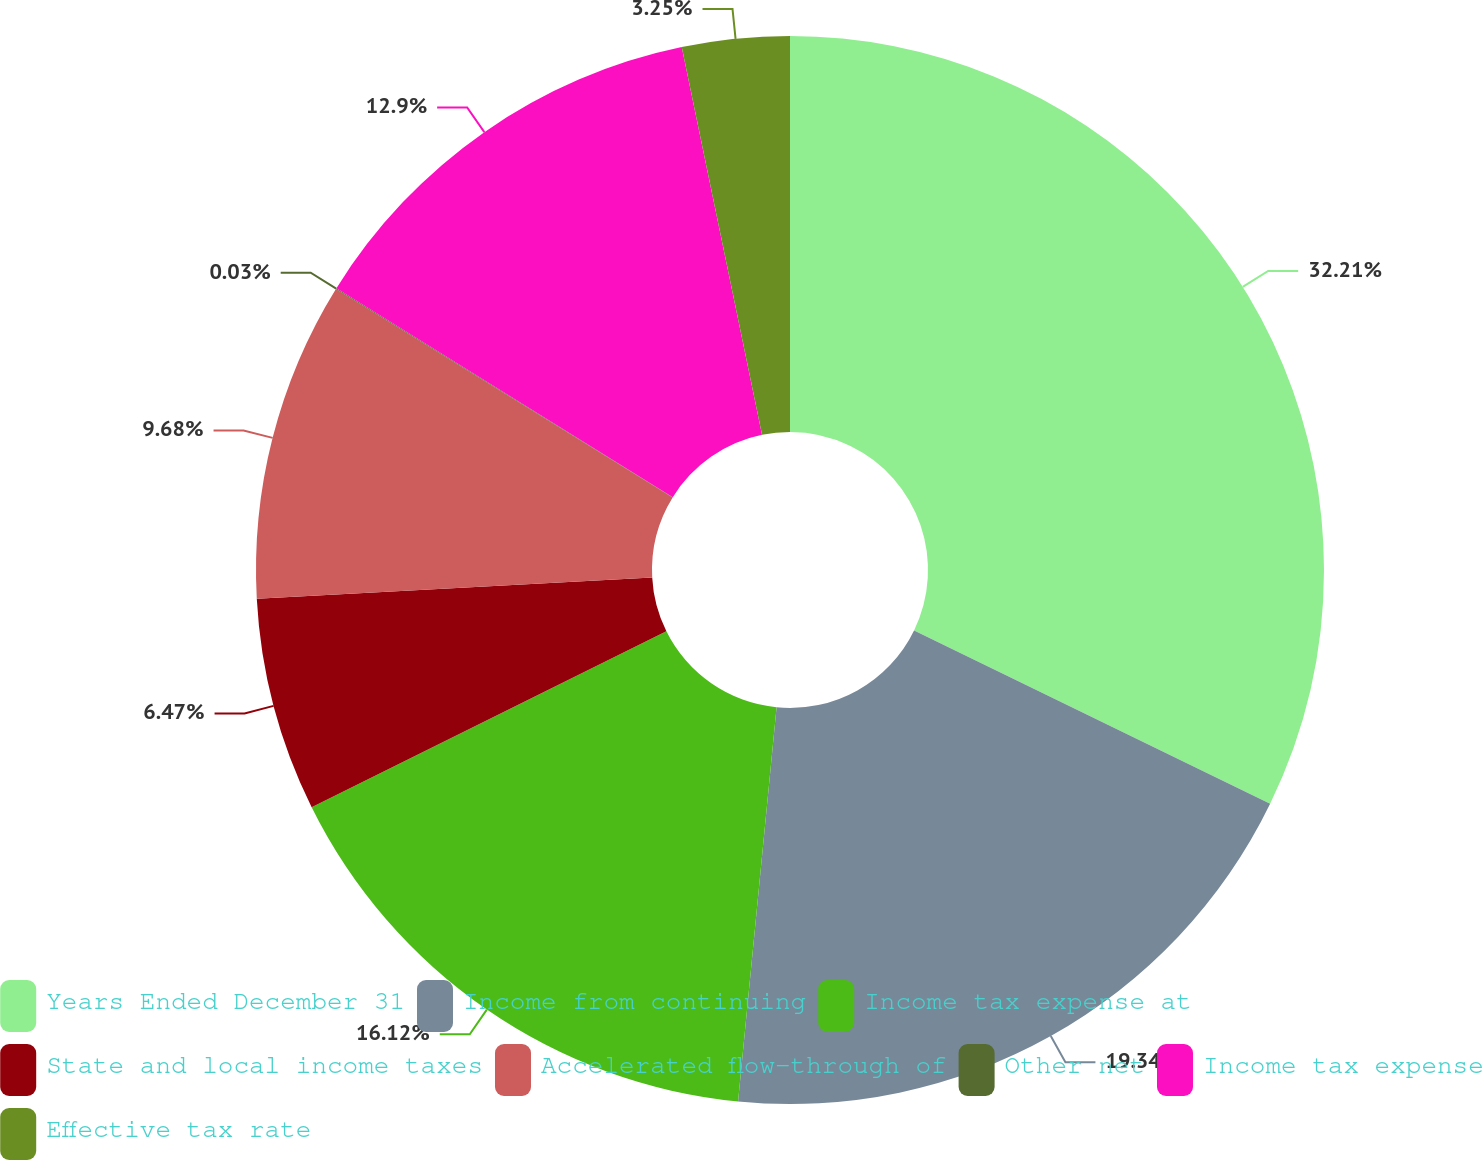Convert chart. <chart><loc_0><loc_0><loc_500><loc_500><pie_chart><fcel>Years Ended December 31<fcel>Income from continuing<fcel>Income tax expense at<fcel>State and local income taxes<fcel>Accelerated flow-through of<fcel>Other net<fcel>Income tax expense<fcel>Effective tax rate<nl><fcel>32.21%<fcel>19.34%<fcel>16.12%<fcel>6.47%<fcel>9.68%<fcel>0.03%<fcel>12.9%<fcel>3.25%<nl></chart> 